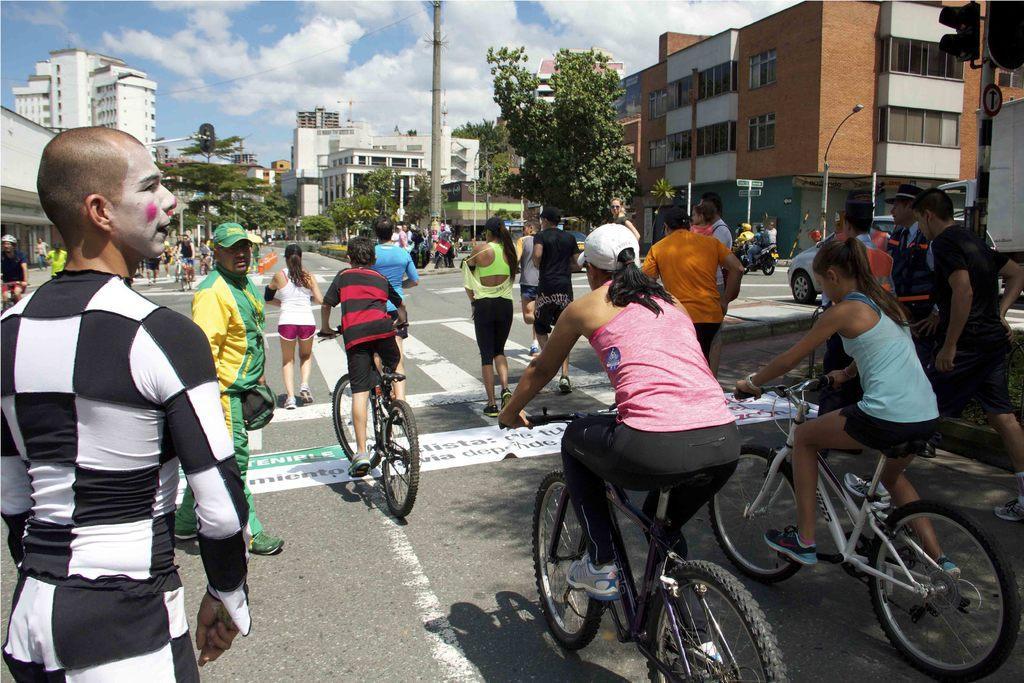How would you summarize this image in a sentence or two? In this image I can see two women and one boy is riding bicycle. And a group of people are standing near the pole. I can see a man walking. At background I can see tree,building,and some vehicles are passing by the road. At the right corner of the image I can see the traffic signal. At the top of the image I can see the sky and clouds. 